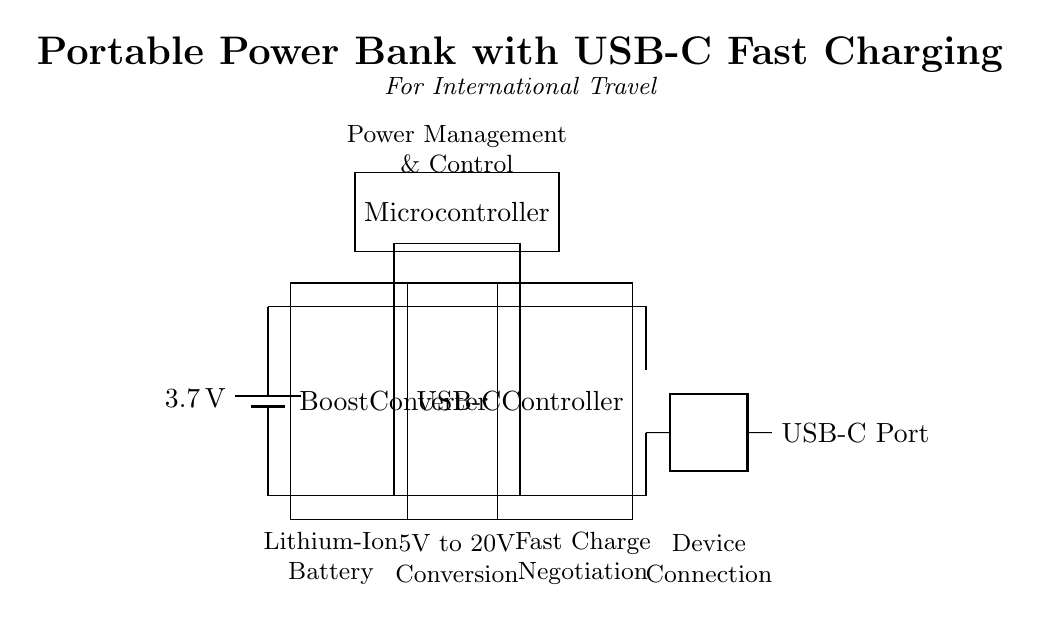What type of battery is used in this circuit? The diagram explicitly labels the battery as a lithium-ion type, which is commonly used for rechargeable devices.
Answer: Lithium-Ion What is the output voltage of the boost converter? The boost converter typically steps up voltage; in this case, it would convert from a default battery voltage of 3.7 volts to a higher output suitable for USB standards. The specific output is not labeled, but USB-C devices often recharge at 5V to 20V, implying the boost converter manages this range.
Answer: 5V to 20V What component is labeled as managing power? The section in the diagram labeled "Power Management & Control" signifies the microcontroller's role in regulating power distribution and charging protocols.
Answer: Microcontroller How does the circuit connect the battery to the USB-C port? The circuit shows direct lines indicating the flow from the battery through the boost converter, then to the USB-C controller, leading to the USB-C port. The arrows illustrate connectivity along these paths, showing a sequential link.
Answer: Through connections Which device negotiates fast charging? The section labeled "Fast Charge Negotiation" indicates that the USB-C controller is responsible for managing the communication necessary for fast charging capabilities between the power bank and connected devices.
Answer: USB-C Controller What is the primary function of the boost converter in this circuit? The boost converter is designed to increase the battery's voltage from 3.7 volts to the higher outputs required for efficient charging of devices connected through USB-C. The conversion from a lower to a higher voltage is essential for compatibility with a range of electronics.
Answer: Voltage Increase How is the communication handled for charging? The USB-C controller facilitates charge negotiation, allowing connected devices to communicate their charging requirements, which the controller uses to adjust the power output accordingly. It's critical for ensuring safe and efficient charging.
Answer: Via USB-C Controller 